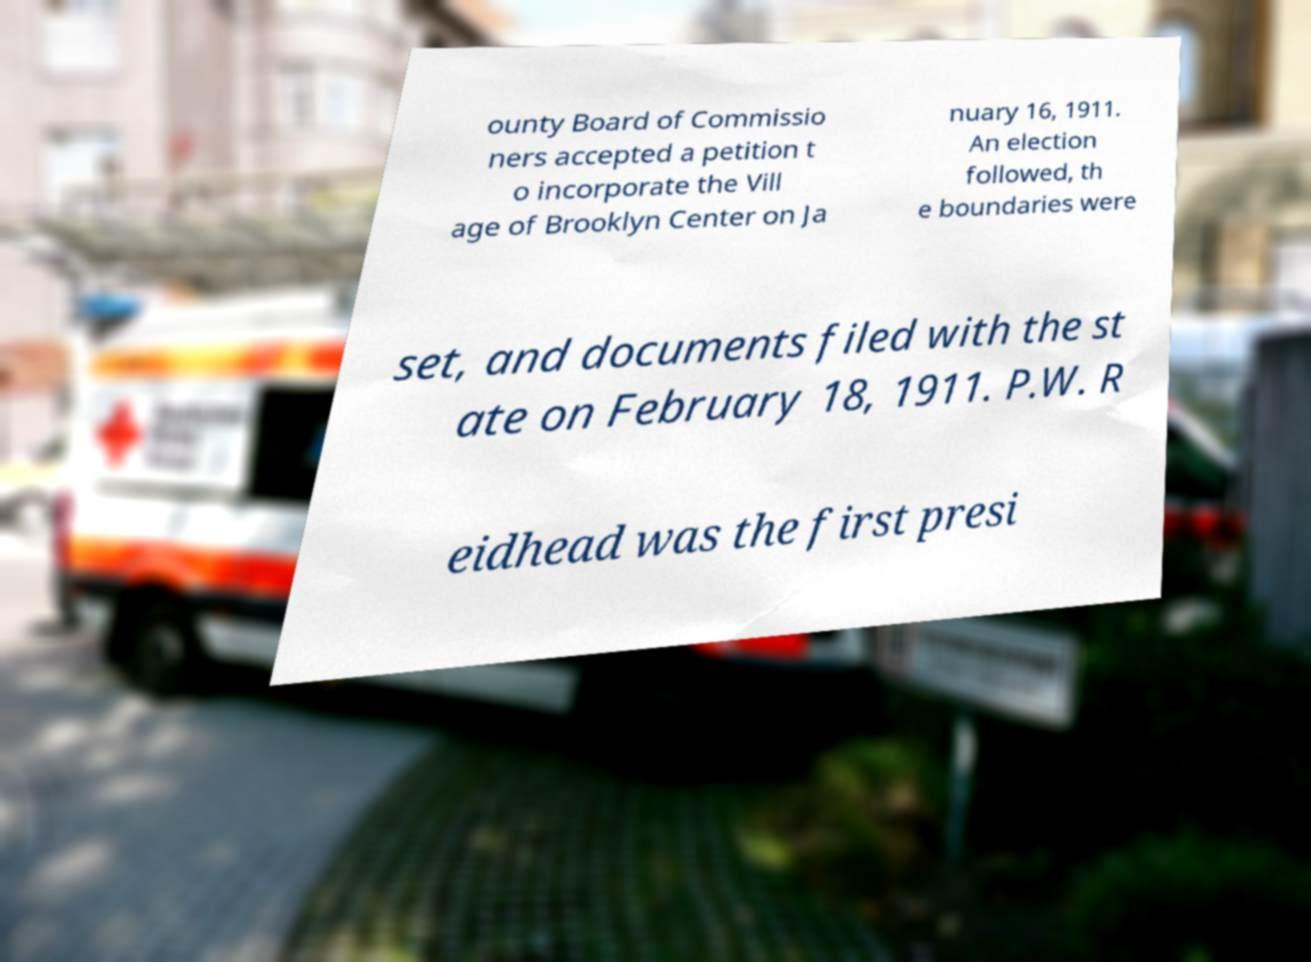For documentation purposes, I need the text within this image transcribed. Could you provide that? ounty Board of Commissio ners accepted a petition t o incorporate the Vill age of Brooklyn Center on Ja nuary 16, 1911. An election followed, th e boundaries were set, and documents filed with the st ate on February 18, 1911. P.W. R eidhead was the first presi 